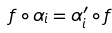<formula> <loc_0><loc_0><loc_500><loc_500>f \circ \alpha _ { i } = \alpha ^ { \prime } _ { i } \circ f</formula> 